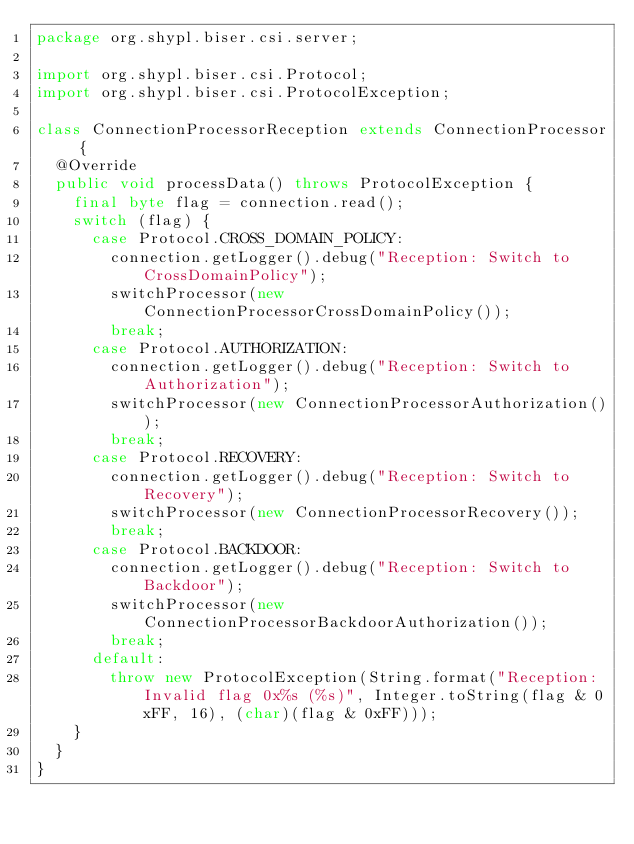Convert code to text. <code><loc_0><loc_0><loc_500><loc_500><_Java_>package org.shypl.biser.csi.server;

import org.shypl.biser.csi.Protocol;
import org.shypl.biser.csi.ProtocolException;

class ConnectionProcessorReception extends ConnectionProcessor {
	@Override
	public void processData() throws ProtocolException {
		final byte flag = connection.read();
		switch (flag) {
			case Protocol.CROSS_DOMAIN_POLICY:
				connection.getLogger().debug("Reception: Switch to CrossDomainPolicy");
				switchProcessor(new ConnectionProcessorCrossDomainPolicy());
				break;
			case Protocol.AUTHORIZATION:
				connection.getLogger().debug("Reception: Switch to Authorization");
				switchProcessor(new ConnectionProcessorAuthorization());
				break;
			case Protocol.RECOVERY:
				connection.getLogger().debug("Reception: Switch to Recovery");
				switchProcessor(new ConnectionProcessorRecovery());
				break;
			case Protocol.BACKDOOR:
				connection.getLogger().debug("Reception: Switch to Backdoor");
				switchProcessor(new ConnectionProcessorBackdoorAuthorization());
				break;
			default:
				throw new ProtocolException(String.format("Reception: Invalid flag 0x%s (%s)", Integer.toString(flag & 0xFF, 16), (char)(flag & 0xFF)));
		}
	}
}
</code> 